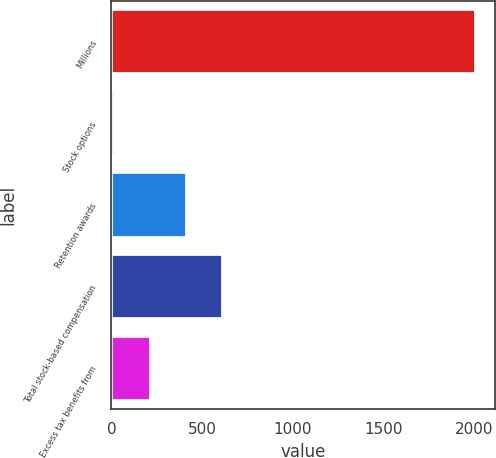<chart> <loc_0><loc_0><loc_500><loc_500><bar_chart><fcel>Millions<fcel>Stock options<fcel>Retention awards<fcel>Total stock-based compensation<fcel>Excess tax benefits from<nl><fcel>2015<fcel>17<fcel>416.6<fcel>616.4<fcel>216.8<nl></chart> 